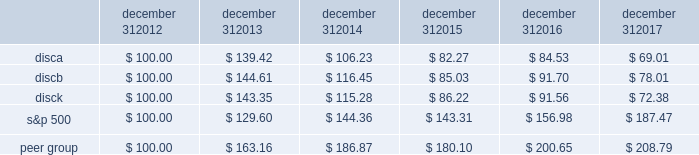Part ii item 5 .
Market for registrant 2019s common equity , related stockholder matters and issuer purchases of equity securities .
Our series a common stock , series b common stock and series c common stock are listed and traded on the nasdaq global select market ( 201cnasdaq 201d ) under the symbols 201cdisca , 201d 201cdiscb 201d and 201cdisck , 201d respectively .
The table sets forth , for the periods indicated , the range of high and low sales prices per share of our series a common stock , series b common stock and series c common stock as reported on yahoo! finance ( finance.yahoo.com ) .
Series a common stock series b common stock series c common stock high low high low high low fourth quarter $ 23.73 $ 16.28 $ 26.80 $ 20.00 $ 22.47 $ 15.27 third quarter $ 27.18 $ 20.80 $ 27.90 $ 22.00 $ 26.21 $ 19.62 second quarter $ 29.40 $ 25.11 $ 29.55 $ 25.45 $ 28.90 $ 24.39 first quarter $ 29.62 $ 26.34 $ 29.65 $ 27.55 $ 28.87 $ 25.76 fourth quarter $ 29.55 $ 25.01 $ 30.50 $ 26.00 $ 28.66 $ 24.20 third quarter $ 26.97 $ 24.27 $ 28.00 $ 25.21 $ 26.31 $ 23.44 second quarter $ 29.31 $ 23.73 $ 29.34 $ 24.15 $ 28.48 $ 22.54 first quarter $ 29.42 $ 24.33 $ 29.34 $ 24.30 $ 28.00 $ 23.81 as of february 21 , 2018 , there were approximately 1308 , 75 and 1414 record holders of our series a common stock , series b common stock and series c common stock , respectively .
These amounts do not include the number of shareholders whose shares are held of record by banks , brokerage houses or other institutions , but include each such institution as one shareholder .
We have not paid any cash dividends on our series a common stock , series b common stock or series c common stock , and we have no present intention to do so .
Payment of cash dividends , if any , will be determined by our board of directors after consideration of our earnings , financial condition and other relevant factors such as our credit facility's restrictions on our ability to declare dividends in certain situations .
Purchases of equity securities the table presents information about our repurchases of common stock that were made through open market transactions during the three months ended december 31 , 2017 ( in millions , except per share amounts ) .
Period total number of series c shares purchased average paid per share : series c ( a ) total number of shares purchased as part of publicly announced plans or programs ( b ) ( c ) approximate dollar value of shares that may yet be purchased under the plans or programs ( a ) ( b ) october 1 , 2017 - october 31 , 2017 2014 $ 2014 2014 $ 2014 november 1 , 2017 - november 30 , 2017 2014 $ 2014 2014 $ 2014 december 1 , 2017 - december 31 , 2017 2014 $ 2014 2014 $ 2014 total 2014 2014 $ 2014 ( a ) the amounts do not give effect to any fees , commissions or other costs associated with repurchases of shares .
( b ) under the stock repurchase program , management was authorized to purchase shares of the company's common stock from time to time through open market purchases or privately negotiated transactions at prevailing prices or pursuant to one or more accelerated stock repurchase agreements or other derivative arrangements as permitted by securities laws and other legal requirements , and subject to stock price , business and market conditions and other factors .
The company's authorization under the program expired on october 8 , 2017 and we have not repurchased any shares of common stock since then .
We historically have funded and in the future may fund stock repurchases through a combination of cash on hand and cash generated by operations and the issuance of debt .
In the future , if further authorization is provided , we may also choose to fund stock repurchases through borrowings under our revolving credit facility or future financing transactions .
There were no repurchases of our series a and b common stock during 2017 and no repurchases of series c common stock during the three months ended december 31 , 2017 .
The company first announced its stock repurchase program on august 3 , 2010 .
( c ) we entered into an agreement with advance/newhouse to repurchase , on a quarterly basis , a number of shares of series c-1 convertible preferred stock convertible into a number of shares of series c common stock .
We did not convert any any shares of series c-1 convertible preferred stock during the three months ended december 31 , 2017 .
There are no planned repurchases of series c-1 convertible preferred stock for the first quarter of 2018 as there were no repurchases of series a or series c common stock during the three months ended december 31 , 2017 .
Stock performance graph the following graph sets forth the cumulative total shareholder return on our series a common stock , series b common stock and series c common stock as compared with the cumulative total return of the companies listed in the standard and poor 2019s 500 stock index ( 201cs&p 500 index 201d ) and a peer group of companies comprised of cbs corporation class b common stock , scripps network interactive , inc. , time warner , inc. , twenty-first century fox , inc .
Class a common stock ( news corporation class a common stock prior to june 2013 ) , viacom , inc .
Class b common stock and the walt disney company .
The graph assumes $ 100 originally invested on december 31 , 2012 in each of our series a common stock , series b common stock and series c common stock , the s&p 500 index , and the stock of our peer group companies , including reinvestment of dividends , for the years ended december 31 , 2013 , 2014 , 2015 , 2016 and 2017 .
December 31 , december 31 , december 31 , december 31 , december 31 , december 31 .

What was the percentage cumulative total shareholder return on disca common stock for the five year period ended december 31 , 2017? 
Computations: ((78.01 - 100) / 100)
Answer: -0.2199. 